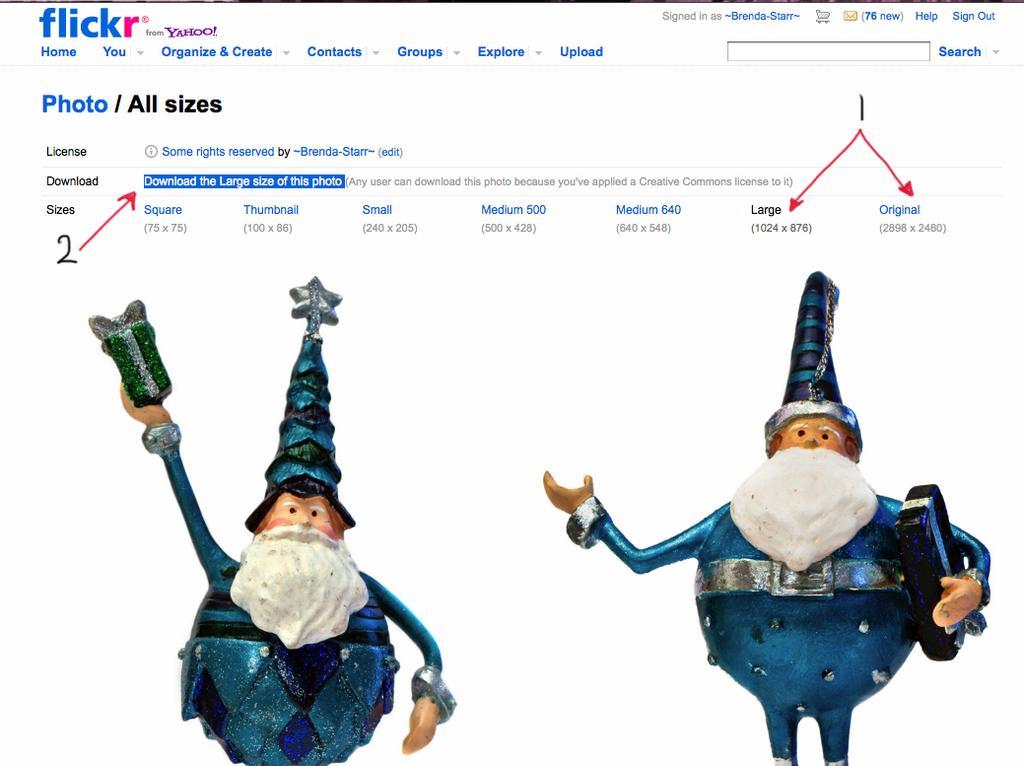Describe this image in one or two sentences. In this image, we can see a page. In this page, we can see toys. Top of the image, we can see some text and arrows. 